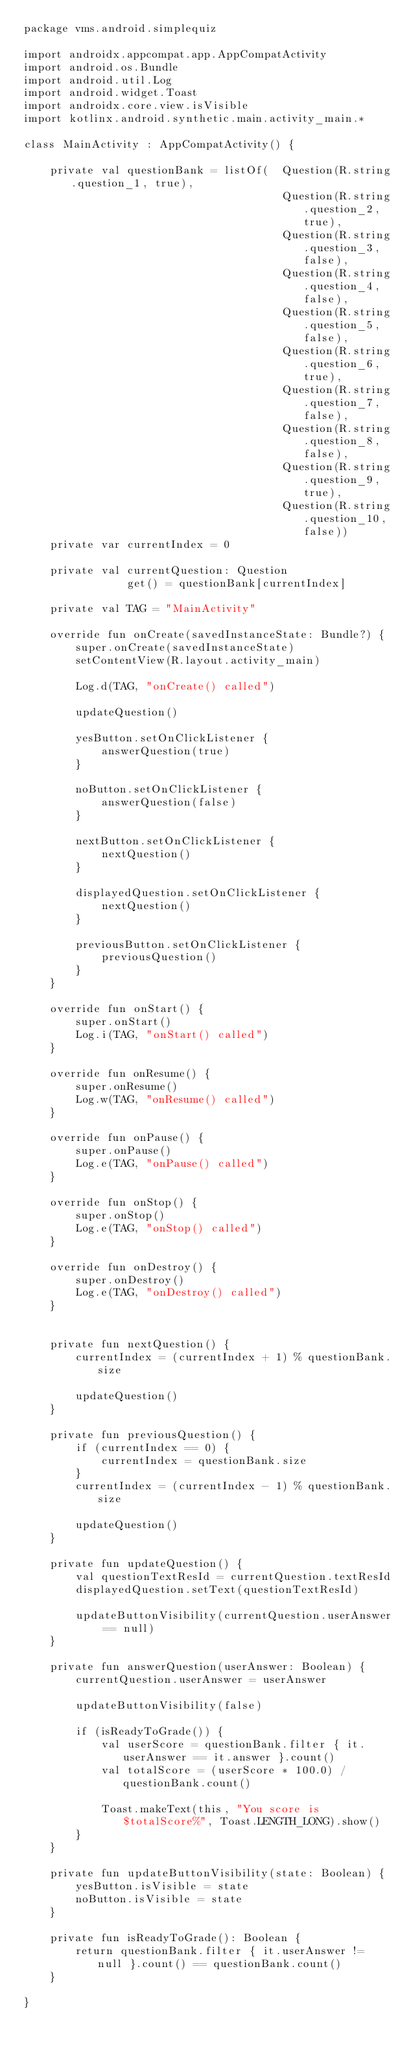<code> <loc_0><loc_0><loc_500><loc_500><_Kotlin_>package vms.android.simplequiz

import androidx.appcompat.app.AppCompatActivity
import android.os.Bundle
import android.util.Log
import android.widget.Toast
import androidx.core.view.isVisible
import kotlinx.android.synthetic.main.activity_main.*

class MainActivity : AppCompatActivity() {

    private val questionBank = listOf(  Question(R.string.question_1, true),
                                        Question(R.string.question_2, true),
                                        Question(R.string.question_3, false),
                                        Question(R.string.question_4, false),
                                        Question(R.string.question_5, false),
                                        Question(R.string.question_6, true),
                                        Question(R.string.question_7, false),
                                        Question(R.string.question_8, false),
                                        Question(R.string.question_9, true),
                                        Question(R.string.question_10, false))
    private var currentIndex = 0

    private val currentQuestion: Question
                get() = questionBank[currentIndex]

    private val TAG = "MainActivity"

    override fun onCreate(savedInstanceState: Bundle?) {
        super.onCreate(savedInstanceState)
        setContentView(R.layout.activity_main)

        Log.d(TAG, "onCreate() called")

        updateQuestion()

        yesButton.setOnClickListener {
            answerQuestion(true)
        }

        noButton.setOnClickListener {
            answerQuestion(false)
        }

        nextButton.setOnClickListener {
            nextQuestion()
        }

        displayedQuestion.setOnClickListener {
            nextQuestion()
        }

        previousButton.setOnClickListener {
            previousQuestion()
        }
    }

    override fun onStart() {
        super.onStart()
        Log.i(TAG, "onStart() called")
    }

    override fun onResume() {
        super.onResume()
        Log.w(TAG, "onResume() called")
    }

    override fun onPause() {
        super.onPause()
        Log.e(TAG, "onPause() called")
    }

    override fun onStop() {
        super.onStop()
        Log.e(TAG, "onStop() called")
    }

    override fun onDestroy() {
        super.onDestroy()
        Log.e(TAG, "onDestroy() called")
    }


    private fun nextQuestion() {
        currentIndex = (currentIndex + 1) % questionBank.size

        updateQuestion()
    }

    private fun previousQuestion() {
        if (currentIndex == 0) {
            currentIndex = questionBank.size
        }
        currentIndex = (currentIndex - 1) % questionBank.size

        updateQuestion()
    }

    private fun updateQuestion() {
        val questionTextResId = currentQuestion.textResId
        displayedQuestion.setText(questionTextResId)

        updateButtonVisibility(currentQuestion.userAnswer == null)
    }

    private fun answerQuestion(userAnswer: Boolean) {
        currentQuestion.userAnswer = userAnswer

        updateButtonVisibility(false)

        if (isReadyToGrade()) {
            val userScore = questionBank.filter { it.userAnswer == it.answer }.count()
            val totalScore = (userScore * 100.0) / questionBank.count()

            Toast.makeText(this, "You score is $totalScore%", Toast.LENGTH_LONG).show()
        }
    }

    private fun updateButtonVisibility(state: Boolean) {
        yesButton.isVisible = state
        noButton.isVisible = state
    }

    private fun isReadyToGrade(): Boolean {
        return questionBank.filter { it.userAnswer != null }.count() == questionBank.count()
    }

}</code> 